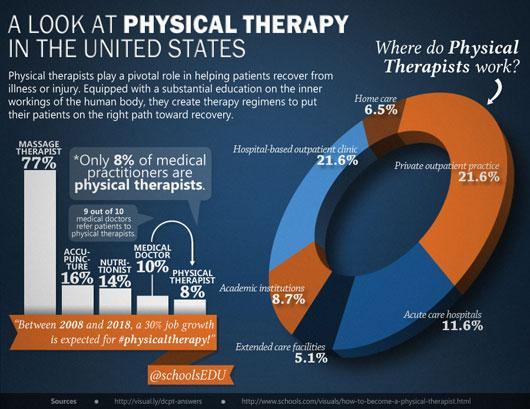Highlight a few significant elements in this photo. According to data, 11.6% of physical therapists work in home care and extended care facilities. According to recent statistics, approximately 16% of practitioners in the field of acupuncture are practitioners. 